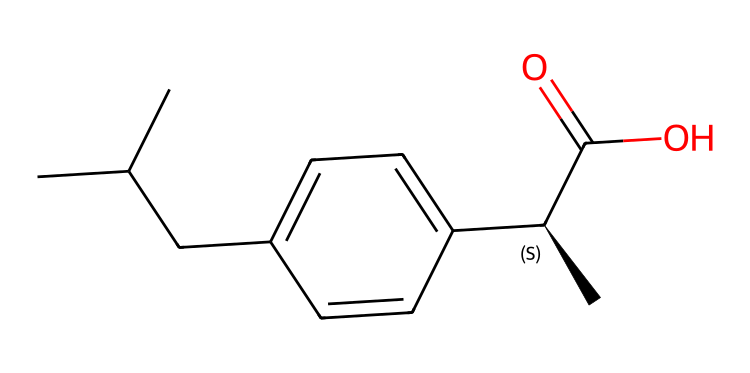How many chiral centers are present in ibuprofen? The chemical structure of ibuprofen contains one chiral center, indicated by the "C@H" notation in the SMILES representation, which designates a carbon atom bonded to four different substituents.
Answer: one What is the molecular formula of ibuprofen? By analyzing the SMILES notation, I can count the carbon (C), hydrogen (H), and oxygen (O) atoms present. The count gives us a molecular formula of C13H18O2.
Answer: C13H18O2 What functional group is present in ibuprofen? The structural representation indicates the presence of a carboxylic acid group (C(=O)O), which is characterized by a carbon atom double-bonded to an oxygen atom and single-bonded to a hydroxyl group.
Answer: carboxylic acid What type of isomerism is exhibited by ibuprofen? As ibuprofen contains a chiral center, it exhibits optical isomerism, where the compound can exist in two enantiomeric forms. This type of isomerism is characteristic of chiral compounds.
Answer: optical isomerism How many rings are present in the structure of ibuprofen? In the SMILES representation, there are no ring structures indicated, as there are no parentheses or numbers showing cycles; ibuprofen is a linear compound in terms of its skeletal structure.
Answer: zero Which part of ibuprofen relates to its anti-inflammatory properties? The presence of the carboxylic acid functional group (C(=O)O) in ibuprofen is crucial as it is involved in the mechanism that inhibits cyclooxygenase enzymes, which are responsible for the inflammation process.
Answer: carboxylic acid 